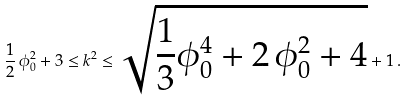Convert formula to latex. <formula><loc_0><loc_0><loc_500><loc_500>\frac { 1 } { 2 } \, \phi _ { 0 } ^ { 2 } + 3 \leq k ^ { 2 } \leq \sqrt { \frac { 1 } { 3 } \phi _ { 0 } ^ { 4 } + 2 \, \phi _ { 0 } ^ { 2 } + 4 } + 1 \, .</formula> 